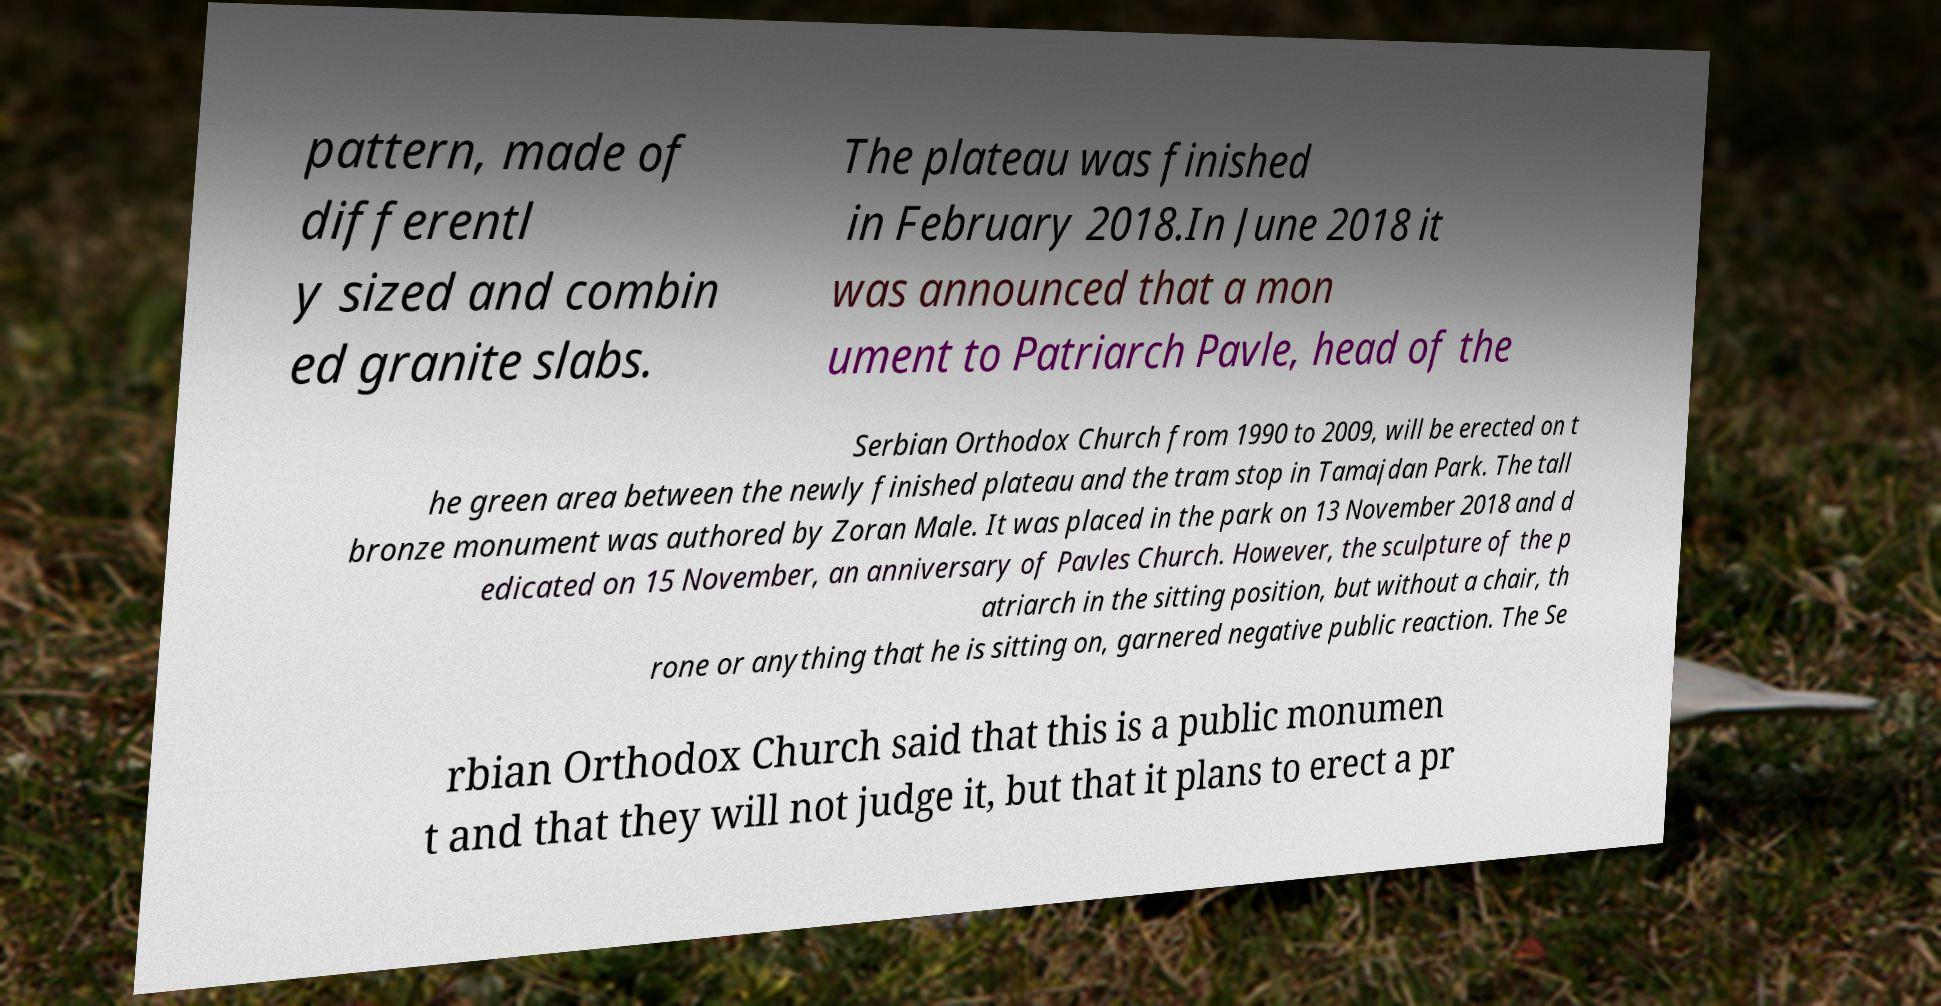I need the written content from this picture converted into text. Can you do that? pattern, made of differentl y sized and combin ed granite slabs. The plateau was finished in February 2018.In June 2018 it was announced that a mon ument to Patriarch Pavle, head of the Serbian Orthodox Church from 1990 to 2009, will be erected on t he green area between the newly finished plateau and the tram stop in Tamajdan Park. The tall bronze monument was authored by Zoran Male. It was placed in the park on 13 November 2018 and d edicated on 15 November, an anniversary of Pavles Church. However, the sculpture of the p atriarch in the sitting position, but without a chair, th rone or anything that he is sitting on, garnered negative public reaction. The Se rbian Orthodox Church said that this is a public monumen t and that they will not judge it, but that it plans to erect a pr 